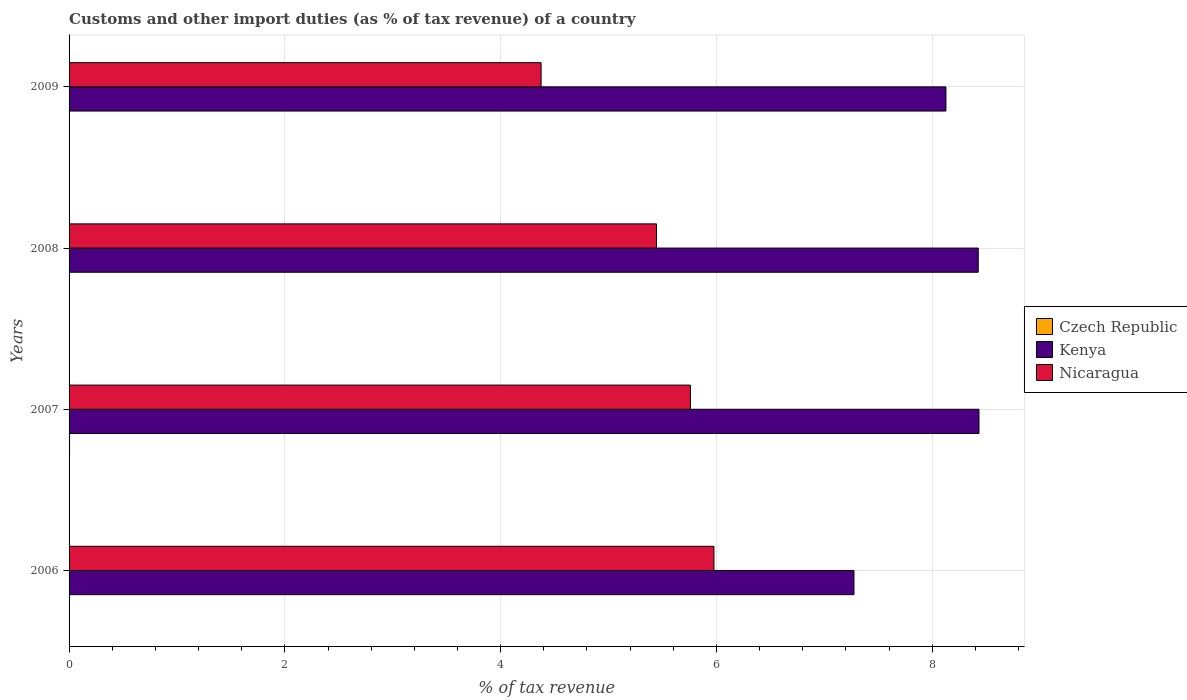Are the number of bars on each tick of the Y-axis equal?
Your answer should be very brief. Yes. What is the label of the 2nd group of bars from the top?
Offer a very short reply. 2008. In how many cases, is the number of bars for a given year not equal to the number of legend labels?
Provide a succinct answer. 0. What is the percentage of tax revenue from customs in Kenya in 2006?
Keep it short and to the point. 7.28. Across all years, what is the maximum percentage of tax revenue from customs in Nicaragua?
Your answer should be very brief. 5.98. Across all years, what is the minimum percentage of tax revenue from customs in Nicaragua?
Give a very brief answer. 4.38. In which year was the percentage of tax revenue from customs in Nicaragua maximum?
Your answer should be compact. 2006. In which year was the percentage of tax revenue from customs in Kenya minimum?
Your response must be concise. 2006. What is the total percentage of tax revenue from customs in Czech Republic in the graph?
Make the answer very short. 0.01. What is the difference between the percentage of tax revenue from customs in Kenya in 2008 and that in 2009?
Make the answer very short. 0.3. What is the difference between the percentage of tax revenue from customs in Nicaragua in 2009 and the percentage of tax revenue from customs in Kenya in 2008?
Make the answer very short. -4.05. What is the average percentage of tax revenue from customs in Czech Republic per year?
Provide a succinct answer. 0. In the year 2009, what is the difference between the percentage of tax revenue from customs in Kenya and percentage of tax revenue from customs in Nicaragua?
Keep it short and to the point. 3.75. In how many years, is the percentage of tax revenue from customs in Kenya greater than 6 %?
Ensure brevity in your answer.  4. What is the ratio of the percentage of tax revenue from customs in Czech Republic in 2008 to that in 2009?
Provide a short and direct response. 1.43. What is the difference between the highest and the second highest percentage of tax revenue from customs in Czech Republic?
Provide a succinct answer. 0. What is the difference between the highest and the lowest percentage of tax revenue from customs in Kenya?
Ensure brevity in your answer.  1.16. In how many years, is the percentage of tax revenue from customs in Kenya greater than the average percentage of tax revenue from customs in Kenya taken over all years?
Give a very brief answer. 3. What does the 2nd bar from the top in 2007 represents?
Provide a succinct answer. Kenya. What does the 3rd bar from the bottom in 2008 represents?
Your answer should be compact. Nicaragua. Is it the case that in every year, the sum of the percentage of tax revenue from customs in Czech Republic and percentage of tax revenue from customs in Nicaragua is greater than the percentage of tax revenue from customs in Kenya?
Ensure brevity in your answer.  No. How many bars are there?
Ensure brevity in your answer.  12. Are all the bars in the graph horizontal?
Ensure brevity in your answer.  Yes. How many years are there in the graph?
Offer a very short reply. 4. Are the values on the major ticks of X-axis written in scientific E-notation?
Your answer should be very brief. No. What is the title of the graph?
Your answer should be compact. Customs and other import duties (as % of tax revenue) of a country. What is the label or title of the X-axis?
Your response must be concise. % of tax revenue. What is the % of tax revenue of Czech Republic in 2006?
Offer a very short reply. 0. What is the % of tax revenue in Kenya in 2006?
Give a very brief answer. 7.28. What is the % of tax revenue of Nicaragua in 2006?
Your answer should be compact. 5.98. What is the % of tax revenue in Czech Republic in 2007?
Make the answer very short. 0. What is the % of tax revenue in Kenya in 2007?
Your response must be concise. 8.43. What is the % of tax revenue of Nicaragua in 2007?
Your answer should be compact. 5.76. What is the % of tax revenue in Czech Republic in 2008?
Ensure brevity in your answer.  0. What is the % of tax revenue in Kenya in 2008?
Your response must be concise. 8.43. What is the % of tax revenue in Nicaragua in 2008?
Your answer should be very brief. 5.44. What is the % of tax revenue of Czech Republic in 2009?
Offer a terse response. 0. What is the % of tax revenue in Kenya in 2009?
Your answer should be compact. 8.13. What is the % of tax revenue in Nicaragua in 2009?
Make the answer very short. 4.38. Across all years, what is the maximum % of tax revenue of Czech Republic?
Make the answer very short. 0. Across all years, what is the maximum % of tax revenue of Kenya?
Ensure brevity in your answer.  8.43. Across all years, what is the maximum % of tax revenue of Nicaragua?
Keep it short and to the point. 5.98. Across all years, what is the minimum % of tax revenue in Czech Republic?
Your response must be concise. 0. Across all years, what is the minimum % of tax revenue of Kenya?
Ensure brevity in your answer.  7.28. Across all years, what is the minimum % of tax revenue of Nicaragua?
Your answer should be compact. 4.38. What is the total % of tax revenue of Czech Republic in the graph?
Your answer should be very brief. 0.01. What is the total % of tax revenue of Kenya in the graph?
Offer a very short reply. 32.26. What is the total % of tax revenue in Nicaragua in the graph?
Your response must be concise. 21.56. What is the difference between the % of tax revenue of Czech Republic in 2006 and that in 2007?
Your answer should be compact. -0. What is the difference between the % of tax revenue of Kenya in 2006 and that in 2007?
Give a very brief answer. -1.16. What is the difference between the % of tax revenue of Nicaragua in 2006 and that in 2007?
Make the answer very short. 0.22. What is the difference between the % of tax revenue of Czech Republic in 2006 and that in 2008?
Offer a very short reply. -0. What is the difference between the % of tax revenue in Kenya in 2006 and that in 2008?
Offer a terse response. -1.15. What is the difference between the % of tax revenue in Nicaragua in 2006 and that in 2008?
Provide a short and direct response. 0.53. What is the difference between the % of tax revenue of Czech Republic in 2006 and that in 2009?
Give a very brief answer. 0. What is the difference between the % of tax revenue in Kenya in 2006 and that in 2009?
Offer a very short reply. -0.85. What is the difference between the % of tax revenue in Nicaragua in 2006 and that in 2009?
Provide a succinct answer. 1.6. What is the difference between the % of tax revenue in Czech Republic in 2007 and that in 2008?
Offer a terse response. 0. What is the difference between the % of tax revenue in Kenya in 2007 and that in 2008?
Ensure brevity in your answer.  0.01. What is the difference between the % of tax revenue in Nicaragua in 2007 and that in 2008?
Give a very brief answer. 0.31. What is the difference between the % of tax revenue in Czech Republic in 2007 and that in 2009?
Ensure brevity in your answer.  0. What is the difference between the % of tax revenue in Kenya in 2007 and that in 2009?
Your answer should be compact. 0.31. What is the difference between the % of tax revenue of Nicaragua in 2007 and that in 2009?
Provide a succinct answer. 1.38. What is the difference between the % of tax revenue of Kenya in 2008 and that in 2009?
Give a very brief answer. 0.3. What is the difference between the % of tax revenue of Nicaragua in 2008 and that in 2009?
Your answer should be very brief. 1.07. What is the difference between the % of tax revenue in Czech Republic in 2006 and the % of tax revenue in Kenya in 2007?
Offer a terse response. -8.43. What is the difference between the % of tax revenue in Czech Republic in 2006 and the % of tax revenue in Nicaragua in 2007?
Offer a very short reply. -5.76. What is the difference between the % of tax revenue of Kenya in 2006 and the % of tax revenue of Nicaragua in 2007?
Provide a short and direct response. 1.52. What is the difference between the % of tax revenue of Czech Republic in 2006 and the % of tax revenue of Kenya in 2008?
Give a very brief answer. -8.43. What is the difference between the % of tax revenue in Czech Republic in 2006 and the % of tax revenue in Nicaragua in 2008?
Give a very brief answer. -5.44. What is the difference between the % of tax revenue of Kenya in 2006 and the % of tax revenue of Nicaragua in 2008?
Your answer should be very brief. 1.83. What is the difference between the % of tax revenue of Czech Republic in 2006 and the % of tax revenue of Kenya in 2009?
Offer a very short reply. -8.13. What is the difference between the % of tax revenue of Czech Republic in 2006 and the % of tax revenue of Nicaragua in 2009?
Your answer should be very brief. -4.37. What is the difference between the % of tax revenue in Kenya in 2006 and the % of tax revenue in Nicaragua in 2009?
Provide a succinct answer. 2.9. What is the difference between the % of tax revenue of Czech Republic in 2007 and the % of tax revenue of Kenya in 2008?
Ensure brevity in your answer.  -8.42. What is the difference between the % of tax revenue in Czech Republic in 2007 and the % of tax revenue in Nicaragua in 2008?
Give a very brief answer. -5.44. What is the difference between the % of tax revenue in Kenya in 2007 and the % of tax revenue in Nicaragua in 2008?
Offer a terse response. 2.99. What is the difference between the % of tax revenue of Czech Republic in 2007 and the % of tax revenue of Kenya in 2009?
Give a very brief answer. -8.12. What is the difference between the % of tax revenue in Czech Republic in 2007 and the % of tax revenue in Nicaragua in 2009?
Your response must be concise. -4.37. What is the difference between the % of tax revenue in Kenya in 2007 and the % of tax revenue in Nicaragua in 2009?
Your answer should be compact. 4.06. What is the difference between the % of tax revenue of Czech Republic in 2008 and the % of tax revenue of Kenya in 2009?
Keep it short and to the point. -8.13. What is the difference between the % of tax revenue in Czech Republic in 2008 and the % of tax revenue in Nicaragua in 2009?
Offer a terse response. -4.37. What is the difference between the % of tax revenue in Kenya in 2008 and the % of tax revenue in Nicaragua in 2009?
Make the answer very short. 4.05. What is the average % of tax revenue of Czech Republic per year?
Provide a succinct answer. 0. What is the average % of tax revenue in Kenya per year?
Your answer should be very brief. 8.07. What is the average % of tax revenue in Nicaragua per year?
Offer a very short reply. 5.39. In the year 2006, what is the difference between the % of tax revenue in Czech Republic and % of tax revenue in Kenya?
Your answer should be very brief. -7.27. In the year 2006, what is the difference between the % of tax revenue of Czech Republic and % of tax revenue of Nicaragua?
Offer a very short reply. -5.98. In the year 2006, what is the difference between the % of tax revenue of Kenya and % of tax revenue of Nicaragua?
Keep it short and to the point. 1.3. In the year 2007, what is the difference between the % of tax revenue of Czech Republic and % of tax revenue of Kenya?
Give a very brief answer. -8.43. In the year 2007, what is the difference between the % of tax revenue of Czech Republic and % of tax revenue of Nicaragua?
Offer a terse response. -5.75. In the year 2007, what is the difference between the % of tax revenue in Kenya and % of tax revenue in Nicaragua?
Make the answer very short. 2.67. In the year 2008, what is the difference between the % of tax revenue of Czech Republic and % of tax revenue of Kenya?
Make the answer very short. -8.43. In the year 2008, what is the difference between the % of tax revenue of Czech Republic and % of tax revenue of Nicaragua?
Provide a succinct answer. -5.44. In the year 2008, what is the difference between the % of tax revenue of Kenya and % of tax revenue of Nicaragua?
Provide a short and direct response. 2.98. In the year 2009, what is the difference between the % of tax revenue in Czech Republic and % of tax revenue in Kenya?
Provide a succinct answer. -8.13. In the year 2009, what is the difference between the % of tax revenue of Czech Republic and % of tax revenue of Nicaragua?
Keep it short and to the point. -4.37. In the year 2009, what is the difference between the % of tax revenue in Kenya and % of tax revenue in Nicaragua?
Offer a very short reply. 3.75. What is the ratio of the % of tax revenue of Czech Republic in 2006 to that in 2007?
Provide a succinct answer. 0.28. What is the ratio of the % of tax revenue in Kenya in 2006 to that in 2007?
Offer a terse response. 0.86. What is the ratio of the % of tax revenue of Nicaragua in 2006 to that in 2007?
Give a very brief answer. 1.04. What is the ratio of the % of tax revenue of Czech Republic in 2006 to that in 2008?
Ensure brevity in your answer.  0.87. What is the ratio of the % of tax revenue in Kenya in 2006 to that in 2008?
Make the answer very short. 0.86. What is the ratio of the % of tax revenue in Nicaragua in 2006 to that in 2008?
Make the answer very short. 1.1. What is the ratio of the % of tax revenue in Czech Republic in 2006 to that in 2009?
Ensure brevity in your answer.  1.24. What is the ratio of the % of tax revenue of Kenya in 2006 to that in 2009?
Make the answer very short. 0.9. What is the ratio of the % of tax revenue of Nicaragua in 2006 to that in 2009?
Provide a succinct answer. 1.37. What is the ratio of the % of tax revenue in Czech Republic in 2007 to that in 2008?
Ensure brevity in your answer.  3.06. What is the ratio of the % of tax revenue in Kenya in 2007 to that in 2008?
Ensure brevity in your answer.  1. What is the ratio of the % of tax revenue of Nicaragua in 2007 to that in 2008?
Give a very brief answer. 1.06. What is the ratio of the % of tax revenue in Czech Republic in 2007 to that in 2009?
Your answer should be compact. 4.37. What is the ratio of the % of tax revenue in Kenya in 2007 to that in 2009?
Offer a terse response. 1.04. What is the ratio of the % of tax revenue in Nicaragua in 2007 to that in 2009?
Keep it short and to the point. 1.32. What is the ratio of the % of tax revenue of Czech Republic in 2008 to that in 2009?
Provide a short and direct response. 1.43. What is the ratio of the % of tax revenue of Kenya in 2008 to that in 2009?
Offer a very short reply. 1.04. What is the ratio of the % of tax revenue of Nicaragua in 2008 to that in 2009?
Keep it short and to the point. 1.24. What is the difference between the highest and the second highest % of tax revenue in Czech Republic?
Make the answer very short. 0. What is the difference between the highest and the second highest % of tax revenue of Kenya?
Your response must be concise. 0.01. What is the difference between the highest and the second highest % of tax revenue in Nicaragua?
Offer a terse response. 0.22. What is the difference between the highest and the lowest % of tax revenue of Czech Republic?
Your answer should be very brief. 0. What is the difference between the highest and the lowest % of tax revenue in Kenya?
Your answer should be very brief. 1.16. What is the difference between the highest and the lowest % of tax revenue in Nicaragua?
Make the answer very short. 1.6. 